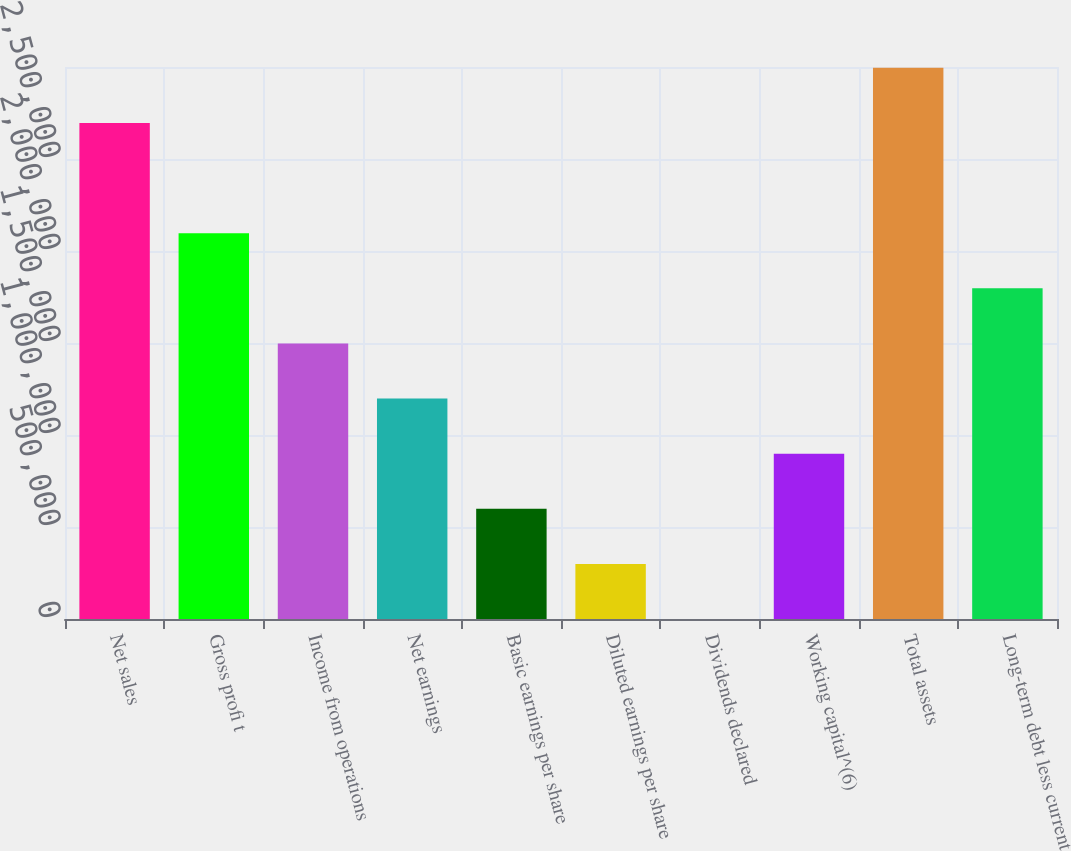Convert chart to OTSL. <chart><loc_0><loc_0><loc_500><loc_500><bar_chart><fcel>Net sales<fcel>Gross profi t<fcel>Income from operations<fcel>Net earnings<fcel>Basic earnings per share<fcel>Diluted earnings per share<fcel>Dividends declared<fcel>Working capital^(6)<fcel>Total assets<fcel>Long-term debt less current<nl><fcel>2.69582e+06<fcel>2.09675e+06<fcel>1.49768e+06<fcel>1.19814e+06<fcel>599072<fcel>299536<fcel>0.24<fcel>898608<fcel>2.99536e+06<fcel>1.79722e+06<nl></chart> 